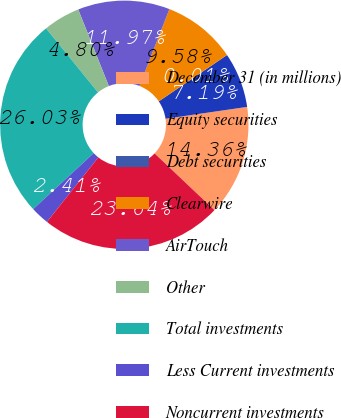Convert chart. <chart><loc_0><loc_0><loc_500><loc_500><pie_chart><fcel>December 31 (in millions)<fcel>Equity securities<fcel>Debt securities<fcel>Clearwire<fcel>AirTouch<fcel>Other<fcel>Total investments<fcel>Less Current investments<fcel>Noncurrent investments<nl><fcel>14.36%<fcel>7.19%<fcel>0.01%<fcel>9.58%<fcel>11.97%<fcel>4.8%<fcel>26.03%<fcel>2.41%<fcel>23.64%<nl></chart> 